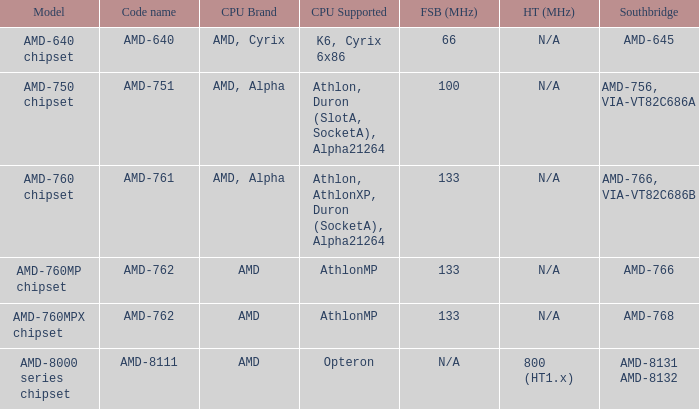What is the code name when the FSB / HT (MHz) is 100 (fsb)? AMD-751. 